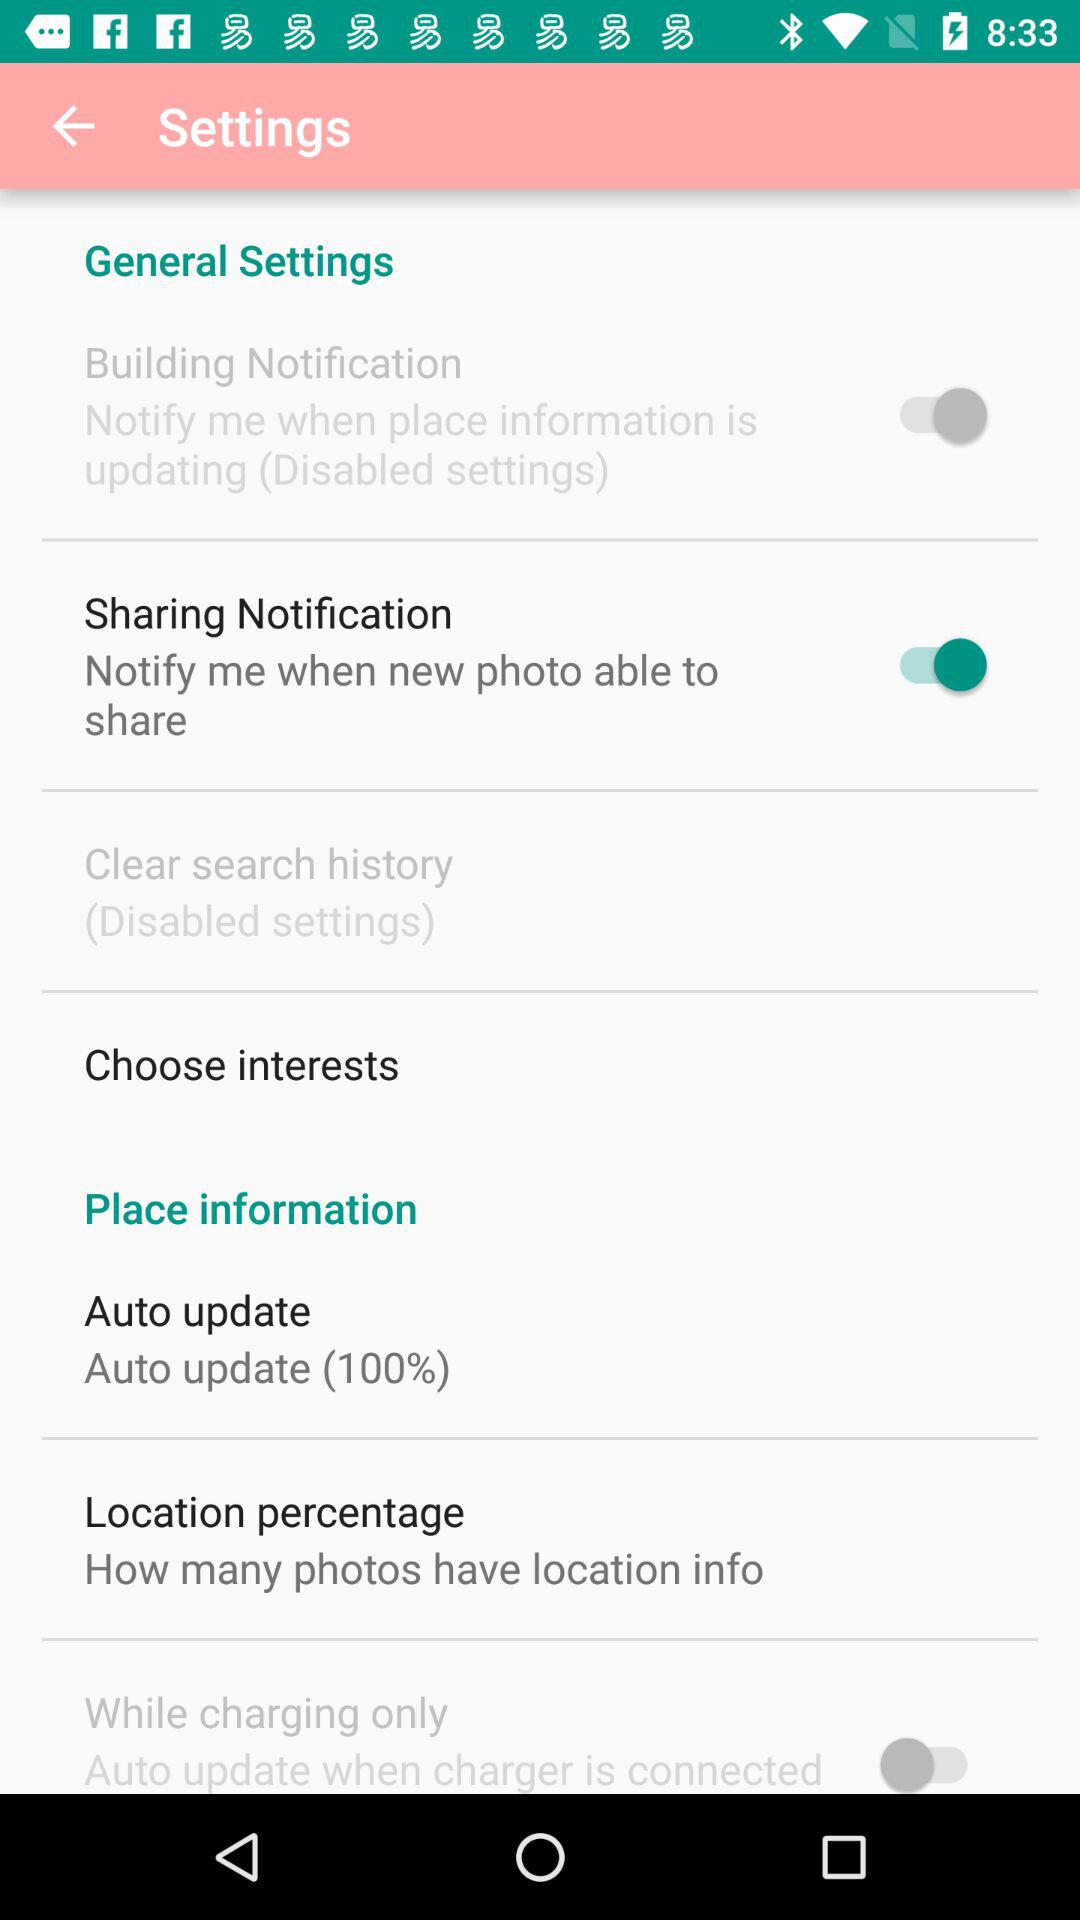What is the status of the building notification? The status is on. 